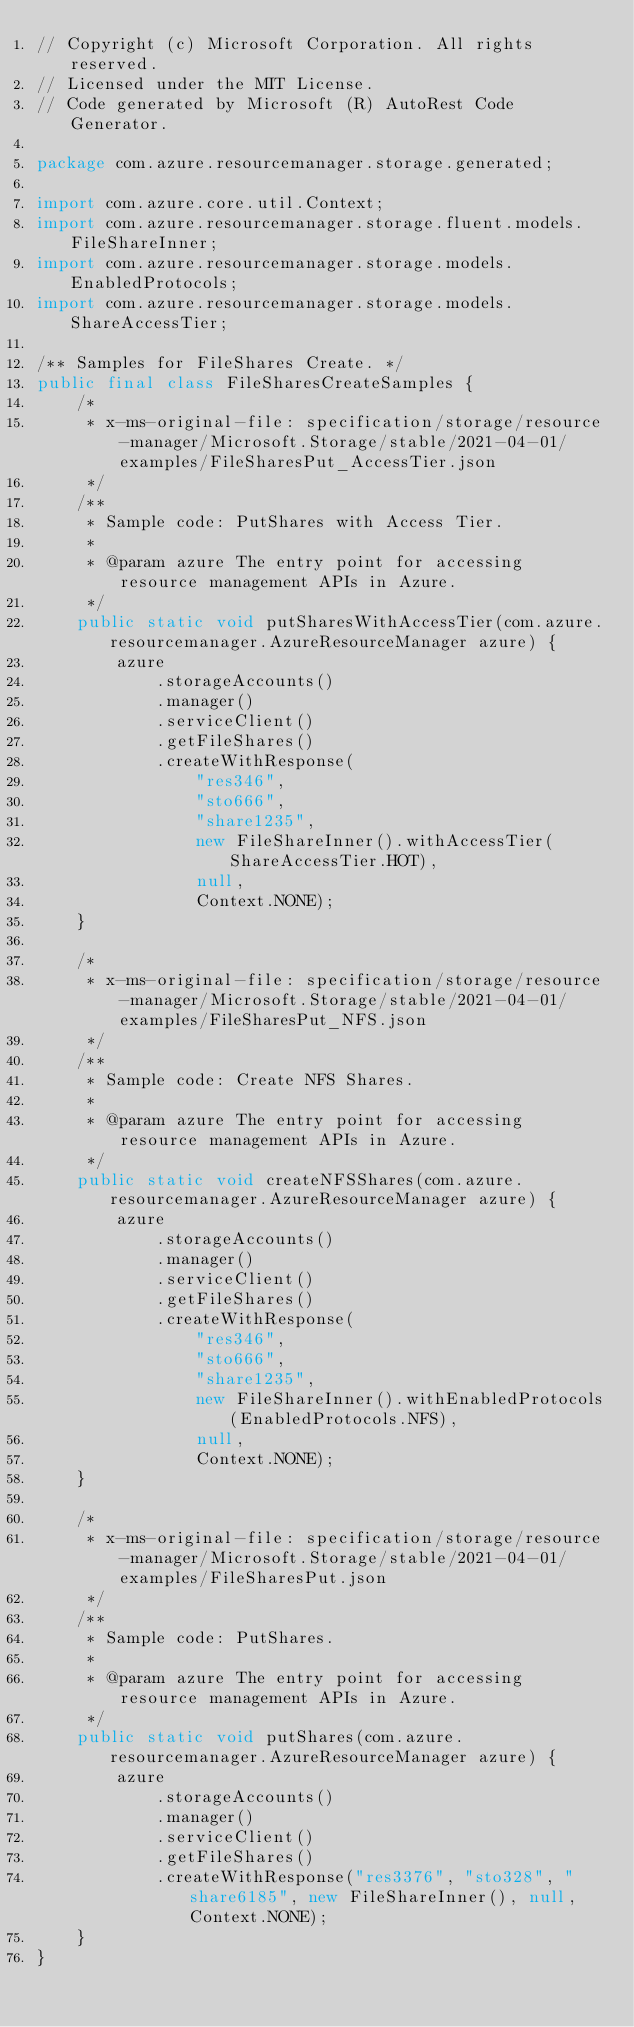<code> <loc_0><loc_0><loc_500><loc_500><_Java_>// Copyright (c) Microsoft Corporation. All rights reserved.
// Licensed under the MIT License.
// Code generated by Microsoft (R) AutoRest Code Generator.

package com.azure.resourcemanager.storage.generated;

import com.azure.core.util.Context;
import com.azure.resourcemanager.storage.fluent.models.FileShareInner;
import com.azure.resourcemanager.storage.models.EnabledProtocols;
import com.azure.resourcemanager.storage.models.ShareAccessTier;

/** Samples for FileShares Create. */
public final class FileSharesCreateSamples {
    /*
     * x-ms-original-file: specification/storage/resource-manager/Microsoft.Storage/stable/2021-04-01/examples/FileSharesPut_AccessTier.json
     */
    /**
     * Sample code: PutShares with Access Tier.
     *
     * @param azure The entry point for accessing resource management APIs in Azure.
     */
    public static void putSharesWithAccessTier(com.azure.resourcemanager.AzureResourceManager azure) {
        azure
            .storageAccounts()
            .manager()
            .serviceClient()
            .getFileShares()
            .createWithResponse(
                "res346",
                "sto666",
                "share1235",
                new FileShareInner().withAccessTier(ShareAccessTier.HOT),
                null,
                Context.NONE);
    }

    /*
     * x-ms-original-file: specification/storage/resource-manager/Microsoft.Storage/stable/2021-04-01/examples/FileSharesPut_NFS.json
     */
    /**
     * Sample code: Create NFS Shares.
     *
     * @param azure The entry point for accessing resource management APIs in Azure.
     */
    public static void createNFSShares(com.azure.resourcemanager.AzureResourceManager azure) {
        azure
            .storageAccounts()
            .manager()
            .serviceClient()
            .getFileShares()
            .createWithResponse(
                "res346",
                "sto666",
                "share1235",
                new FileShareInner().withEnabledProtocols(EnabledProtocols.NFS),
                null,
                Context.NONE);
    }

    /*
     * x-ms-original-file: specification/storage/resource-manager/Microsoft.Storage/stable/2021-04-01/examples/FileSharesPut.json
     */
    /**
     * Sample code: PutShares.
     *
     * @param azure The entry point for accessing resource management APIs in Azure.
     */
    public static void putShares(com.azure.resourcemanager.AzureResourceManager azure) {
        azure
            .storageAccounts()
            .manager()
            .serviceClient()
            .getFileShares()
            .createWithResponse("res3376", "sto328", "share6185", new FileShareInner(), null, Context.NONE);
    }
}
</code> 